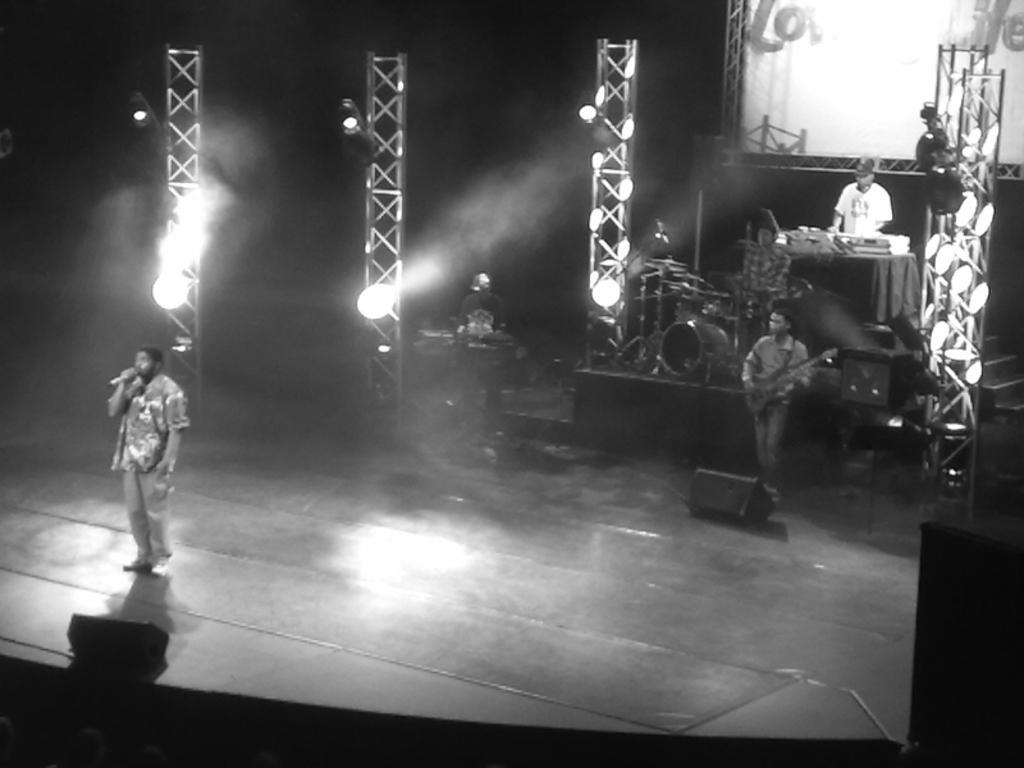Please provide a concise description of this image. This picture is in black and white and it is taken on a stage. On the stage, there is a person towards the left and he is holding a mike. On the top right there are two men playing musical instruments. One person is playing guitar and another person is playing a piano. In the center, there are pillars with lights. On the top right corner there is a screen. 